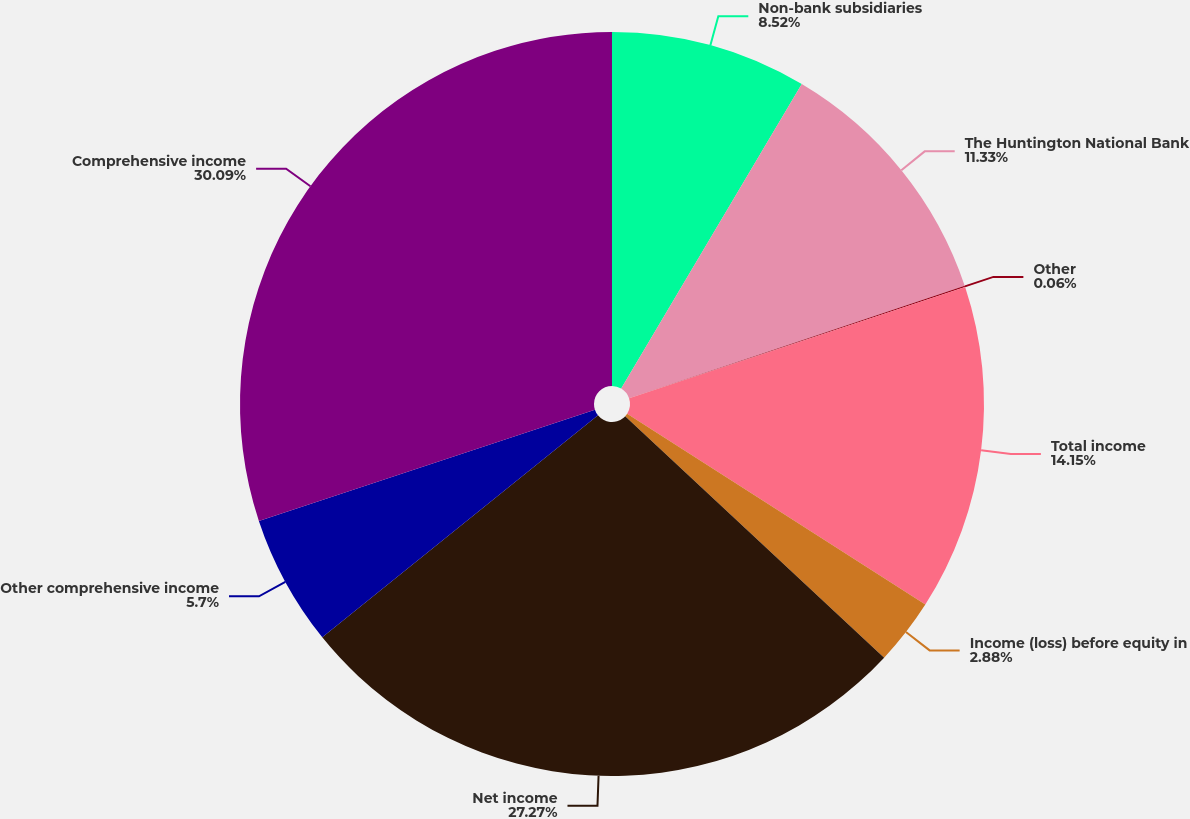<chart> <loc_0><loc_0><loc_500><loc_500><pie_chart><fcel>Non-bank subsidiaries<fcel>The Huntington National Bank<fcel>Other<fcel>Total income<fcel>Income (loss) before equity in<fcel>Net income<fcel>Other comprehensive income<fcel>Comprehensive income<nl><fcel>8.52%<fcel>11.33%<fcel>0.06%<fcel>14.15%<fcel>2.88%<fcel>27.27%<fcel>5.7%<fcel>30.09%<nl></chart> 